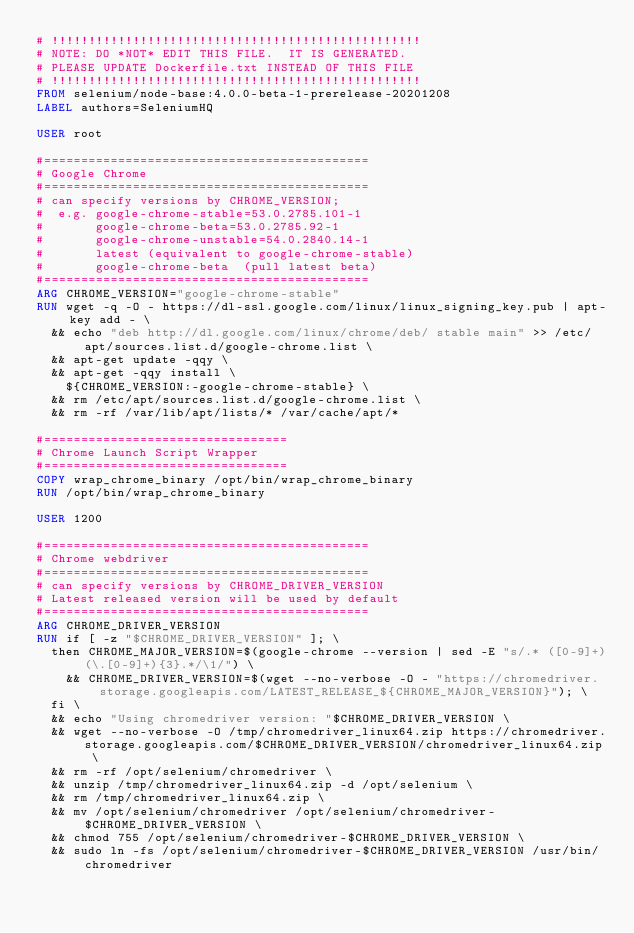Convert code to text. <code><loc_0><loc_0><loc_500><loc_500><_Dockerfile_># !!!!!!!!!!!!!!!!!!!!!!!!!!!!!!!!!!!!!!!!!!!!!!!!!!
# NOTE: DO *NOT* EDIT THIS FILE.  IT IS GENERATED.
# PLEASE UPDATE Dockerfile.txt INSTEAD OF THIS FILE
# !!!!!!!!!!!!!!!!!!!!!!!!!!!!!!!!!!!!!!!!!!!!!!!!!!
FROM selenium/node-base:4.0.0-beta-1-prerelease-20201208
LABEL authors=SeleniumHQ

USER root

#============================================
# Google Chrome
#============================================
# can specify versions by CHROME_VERSION;
#  e.g. google-chrome-stable=53.0.2785.101-1
#       google-chrome-beta=53.0.2785.92-1
#       google-chrome-unstable=54.0.2840.14-1
#       latest (equivalent to google-chrome-stable)
#       google-chrome-beta  (pull latest beta)
#============================================
ARG CHROME_VERSION="google-chrome-stable"
RUN wget -q -O - https://dl-ssl.google.com/linux/linux_signing_key.pub | apt-key add - \
  && echo "deb http://dl.google.com/linux/chrome/deb/ stable main" >> /etc/apt/sources.list.d/google-chrome.list \
  && apt-get update -qqy \
  && apt-get -qqy install \
    ${CHROME_VERSION:-google-chrome-stable} \
  && rm /etc/apt/sources.list.d/google-chrome.list \
  && rm -rf /var/lib/apt/lists/* /var/cache/apt/*

#=================================
# Chrome Launch Script Wrapper
#=================================
COPY wrap_chrome_binary /opt/bin/wrap_chrome_binary
RUN /opt/bin/wrap_chrome_binary

USER 1200

#============================================
# Chrome webdriver
#============================================
# can specify versions by CHROME_DRIVER_VERSION
# Latest released version will be used by default
#============================================
ARG CHROME_DRIVER_VERSION
RUN if [ -z "$CHROME_DRIVER_VERSION" ]; \
  then CHROME_MAJOR_VERSION=$(google-chrome --version | sed -E "s/.* ([0-9]+)(\.[0-9]+){3}.*/\1/") \
    && CHROME_DRIVER_VERSION=$(wget --no-verbose -O - "https://chromedriver.storage.googleapis.com/LATEST_RELEASE_${CHROME_MAJOR_VERSION}"); \
  fi \
  && echo "Using chromedriver version: "$CHROME_DRIVER_VERSION \
  && wget --no-verbose -O /tmp/chromedriver_linux64.zip https://chromedriver.storage.googleapis.com/$CHROME_DRIVER_VERSION/chromedriver_linux64.zip \
  && rm -rf /opt/selenium/chromedriver \
  && unzip /tmp/chromedriver_linux64.zip -d /opt/selenium \
  && rm /tmp/chromedriver_linux64.zip \
  && mv /opt/selenium/chromedriver /opt/selenium/chromedriver-$CHROME_DRIVER_VERSION \
  && chmod 755 /opt/selenium/chromedriver-$CHROME_DRIVER_VERSION \
  && sudo ln -fs /opt/selenium/chromedriver-$CHROME_DRIVER_VERSION /usr/bin/chromedriver
</code> 